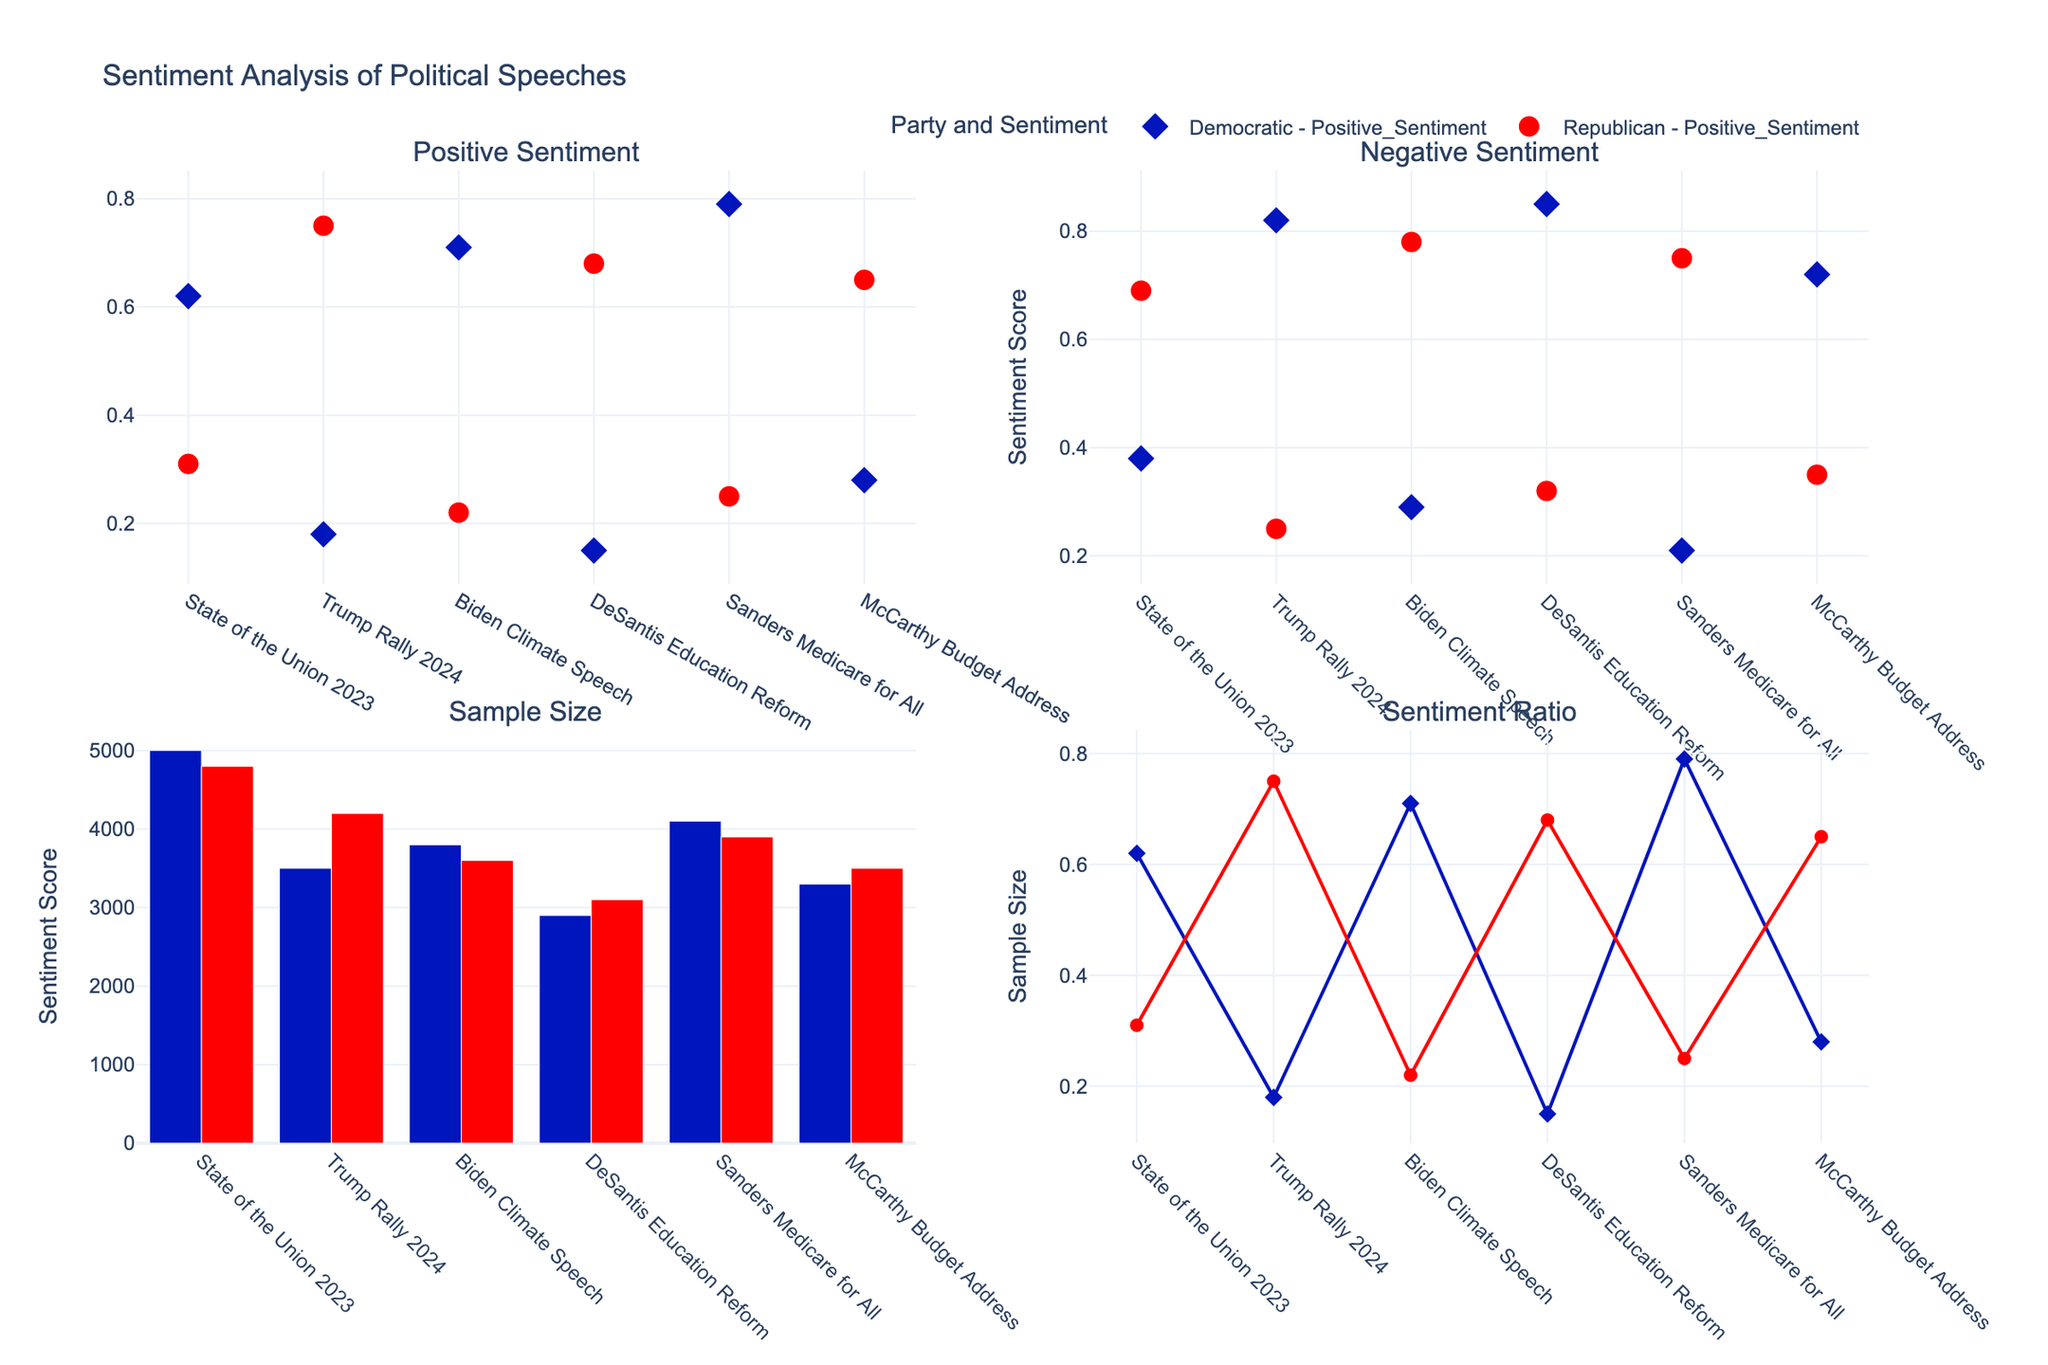what is the positive sentiment score for the Democratic reactions to the "State of the Union 2023" speech? The subplot titled "Positive Sentiment" shows a Democratic marker aligned with the "State of the Union 2023" that is positioned vertically at 0.62.
Answer: 0.62 What speech has the highest sample size for Republican reactions? Refer to the subplot titled "Sample Size" and observe the heights of the bars for Republican data. The highest bar is positioned at "State of the Union 2023."
Answer: State of the Union 2023 Which party shows a higher sentiment ratio for "Biden Climate Speech"? In the "Sentiment Ratio" subplot, compare the heights of the markers corresponding to "Biden Climate Speech" for both the Democratic and Republican parties. The Democratic marker is higher.
Answer: Democratic What is the overall trend for positive sentiments between Republican and Democratic reactions? Examine the first subplot titled "Positive Sentiment." The Democratic markers consistently show higher positive sentiment values compared to Republican markers.
Answer: Democratic higher positive sentiment Which Republicans speech received the highest positive sentiment? Look at the Republican markers in the "Positive Sentiment" subplot. The highest marker corresponds to the "Trump Rally 2024" speech.
Answer: Trump Rally 2024 